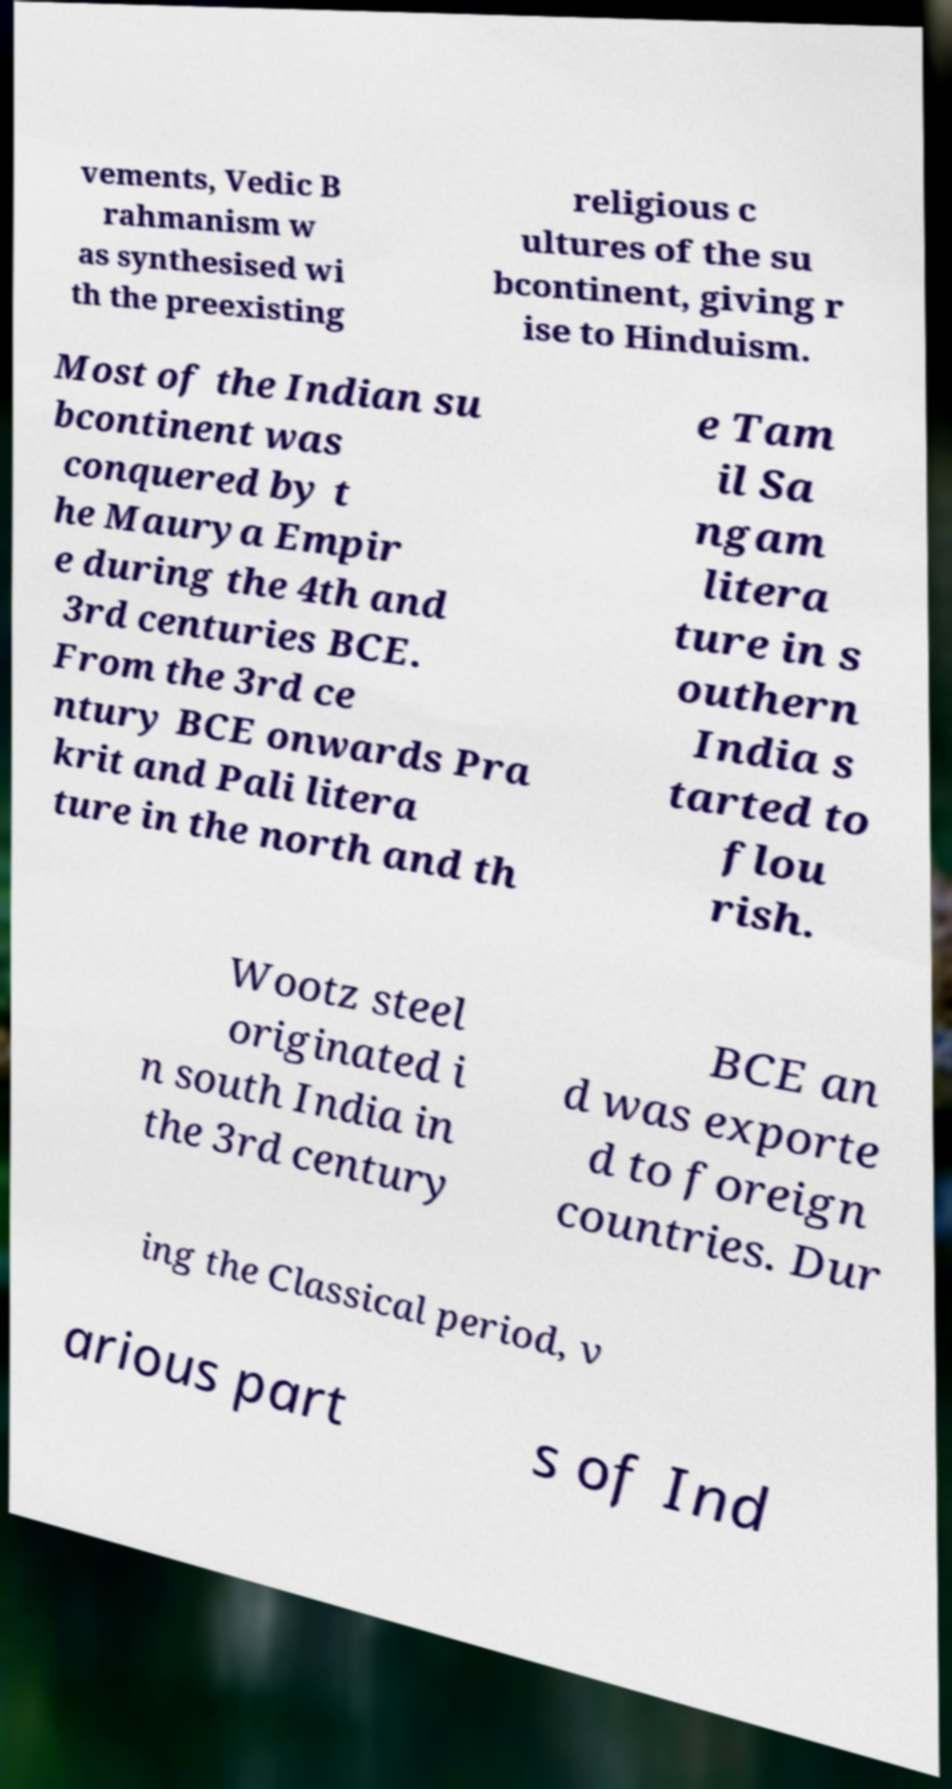For documentation purposes, I need the text within this image transcribed. Could you provide that? vements, Vedic B rahmanism w as synthesised wi th the preexisting religious c ultures of the su bcontinent, giving r ise to Hinduism. Most of the Indian su bcontinent was conquered by t he Maurya Empir e during the 4th and 3rd centuries BCE. From the 3rd ce ntury BCE onwards Pra krit and Pali litera ture in the north and th e Tam il Sa ngam litera ture in s outhern India s tarted to flou rish. Wootz steel originated i n south India in the 3rd century BCE an d was exporte d to foreign countries. Dur ing the Classical period, v arious part s of Ind 